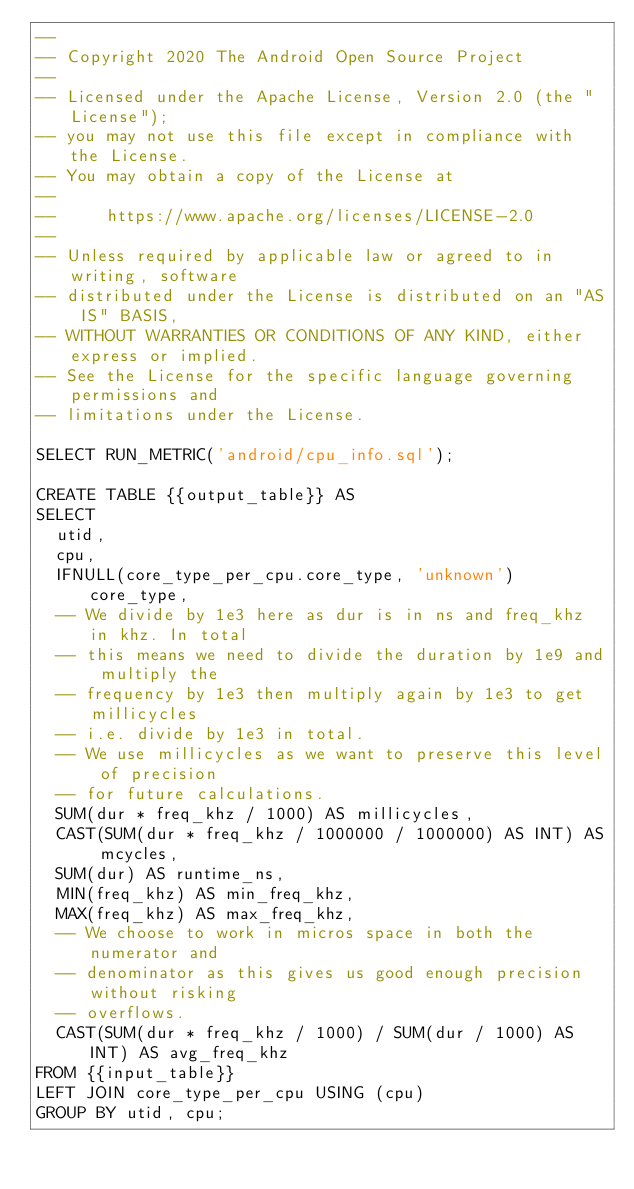<code> <loc_0><loc_0><loc_500><loc_500><_SQL_>--
-- Copyright 2020 The Android Open Source Project
--
-- Licensed under the Apache License, Version 2.0 (the "License");
-- you may not use this file except in compliance with the License.
-- You may obtain a copy of the License at
--
--     https://www.apache.org/licenses/LICENSE-2.0
--
-- Unless required by applicable law or agreed to in writing, software
-- distributed under the License is distributed on an "AS IS" BASIS,
-- WITHOUT WARRANTIES OR CONDITIONS OF ANY KIND, either express or implied.
-- See the License for the specific language governing permissions and
-- limitations under the License.

SELECT RUN_METRIC('android/cpu_info.sql');

CREATE TABLE {{output_table}} AS
SELECT
  utid,
  cpu,
  IFNULL(core_type_per_cpu.core_type, 'unknown') core_type,
  -- We divide by 1e3 here as dur is in ns and freq_khz in khz. In total
  -- this means we need to divide the duration by 1e9 and multiply the
  -- frequency by 1e3 then multiply again by 1e3 to get millicycles
  -- i.e. divide by 1e3 in total.
  -- We use millicycles as we want to preserve this level of precision
  -- for future calculations.
  SUM(dur * freq_khz / 1000) AS millicycles,
  CAST(SUM(dur * freq_khz / 1000000 / 1000000) AS INT) AS mcycles,
  SUM(dur) AS runtime_ns,
  MIN(freq_khz) AS min_freq_khz,
  MAX(freq_khz) AS max_freq_khz,
  -- We choose to work in micros space in both the numerator and
  -- denominator as this gives us good enough precision without risking
  -- overflows.
  CAST(SUM(dur * freq_khz / 1000) / SUM(dur / 1000) AS INT) AS avg_freq_khz
FROM {{input_table}}
LEFT JOIN core_type_per_cpu USING (cpu)
GROUP BY utid, cpu;
</code> 